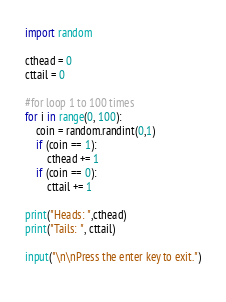Convert code to text. <code><loc_0><loc_0><loc_500><loc_500><_Python_>import random

cthead = 0
cttail = 0

#for loop 1 to 100 times
for i in range(0, 100):
    coin = random.randint(0,1)
    if (coin == 1):
        cthead += 1
    if (coin == 0):
        cttail += 1

print("Heads: ",cthead)
print("Tails: ", cttail)

input("\n\nPress the enter key to exit.")
    </code> 